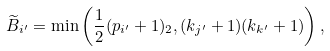Convert formula to latex. <formula><loc_0><loc_0><loc_500><loc_500>\widetilde { B } _ { i ^ { \prime } } = \min \left ( \frac { 1 } { 2 } ( p _ { i ^ { \prime } } + 1 ) _ { 2 } , ( k _ { j ^ { \prime } } + 1 ) ( k _ { k ^ { \prime } } + 1 ) \right ) ,</formula> 